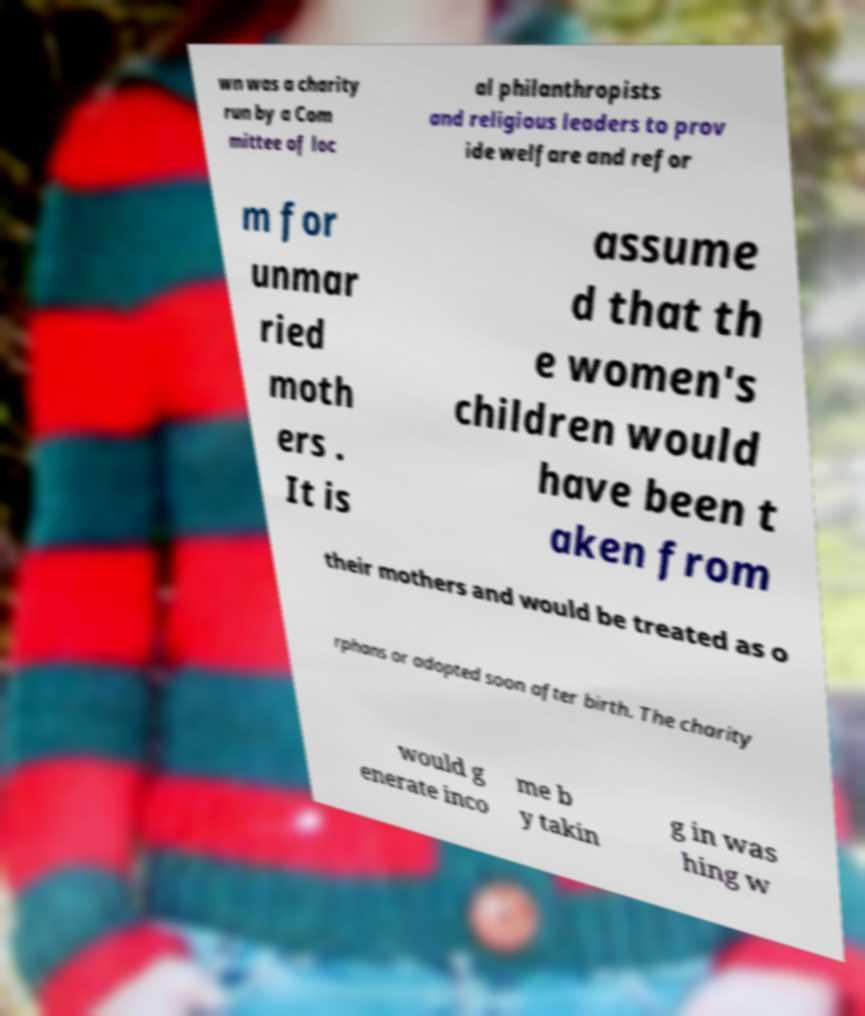Could you assist in decoding the text presented in this image and type it out clearly? wn was a charity run by a Com mittee of loc al philanthropists and religious leaders to prov ide welfare and refor m for unmar ried moth ers . It is assume d that th e women's children would have been t aken from their mothers and would be treated as o rphans or adopted soon after birth. The charity would g enerate inco me b y takin g in was hing w 